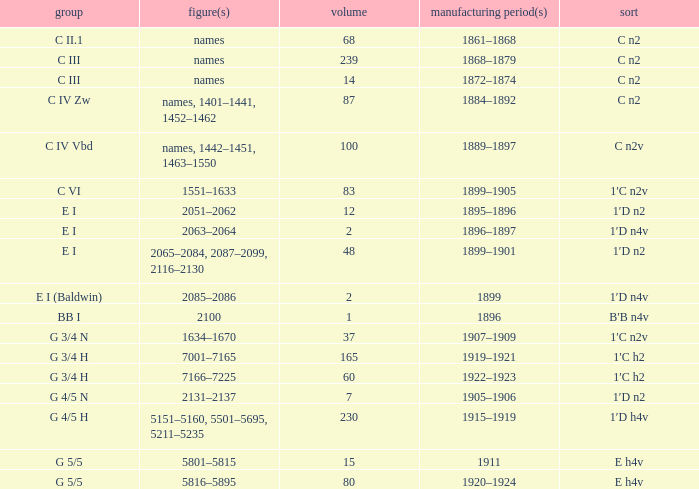Which Class has a Year(s) of Manufacture of 1899? E I (Baldwin). 